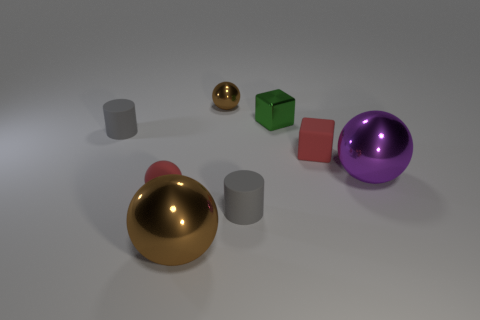Subtract all small brown metal balls. How many balls are left? 3 Add 1 gray spheres. How many objects exist? 9 Subtract all brown balls. How many balls are left? 2 Subtract all green cylinders. How many brown spheres are left? 2 Subtract 2 cylinders. How many cylinders are left? 0 Subtract 2 gray cylinders. How many objects are left? 6 Subtract all cylinders. How many objects are left? 6 Subtract all red cylinders. Subtract all gray blocks. How many cylinders are left? 2 Subtract all big blue metal things. Subtract all red objects. How many objects are left? 6 Add 4 gray cylinders. How many gray cylinders are left? 6 